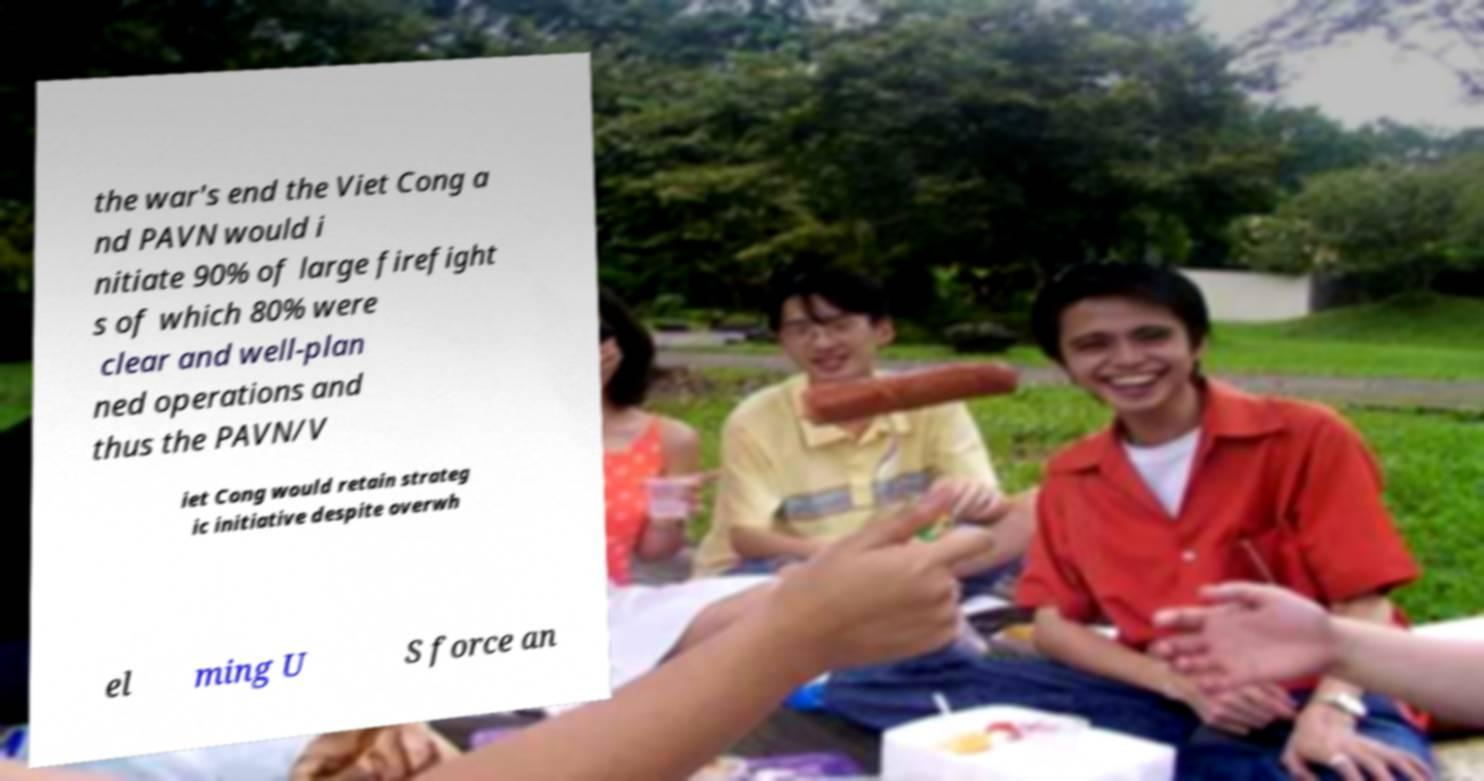What messages or text are displayed in this image? I need them in a readable, typed format. the war's end the Viet Cong a nd PAVN would i nitiate 90% of large firefight s of which 80% were clear and well-plan ned operations and thus the PAVN/V iet Cong would retain strateg ic initiative despite overwh el ming U S force an 